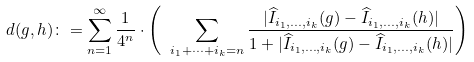Convert formula to latex. <formula><loc_0><loc_0><loc_500><loc_500>d ( g , h ) \colon = \sum _ { n = 1 } ^ { \infty } \frac { 1 } { 4 ^ { n } } \cdot \left ( \ \, \sum _ { i _ { 1 } + \cdots + i _ { k } = n } \frac { | \widehat { I } _ { i _ { 1 } , \dots , i _ { k } } ( g ) - \widehat { I } _ { i _ { 1 } , \dots , i _ { k } } ( h ) | } { 1 + | \widehat { I } _ { i _ { 1 } , \dots , i _ { k } } ( g ) - \widehat { I } _ { i _ { 1 } , \dots , i _ { k } } ( h ) | } \right )</formula> 